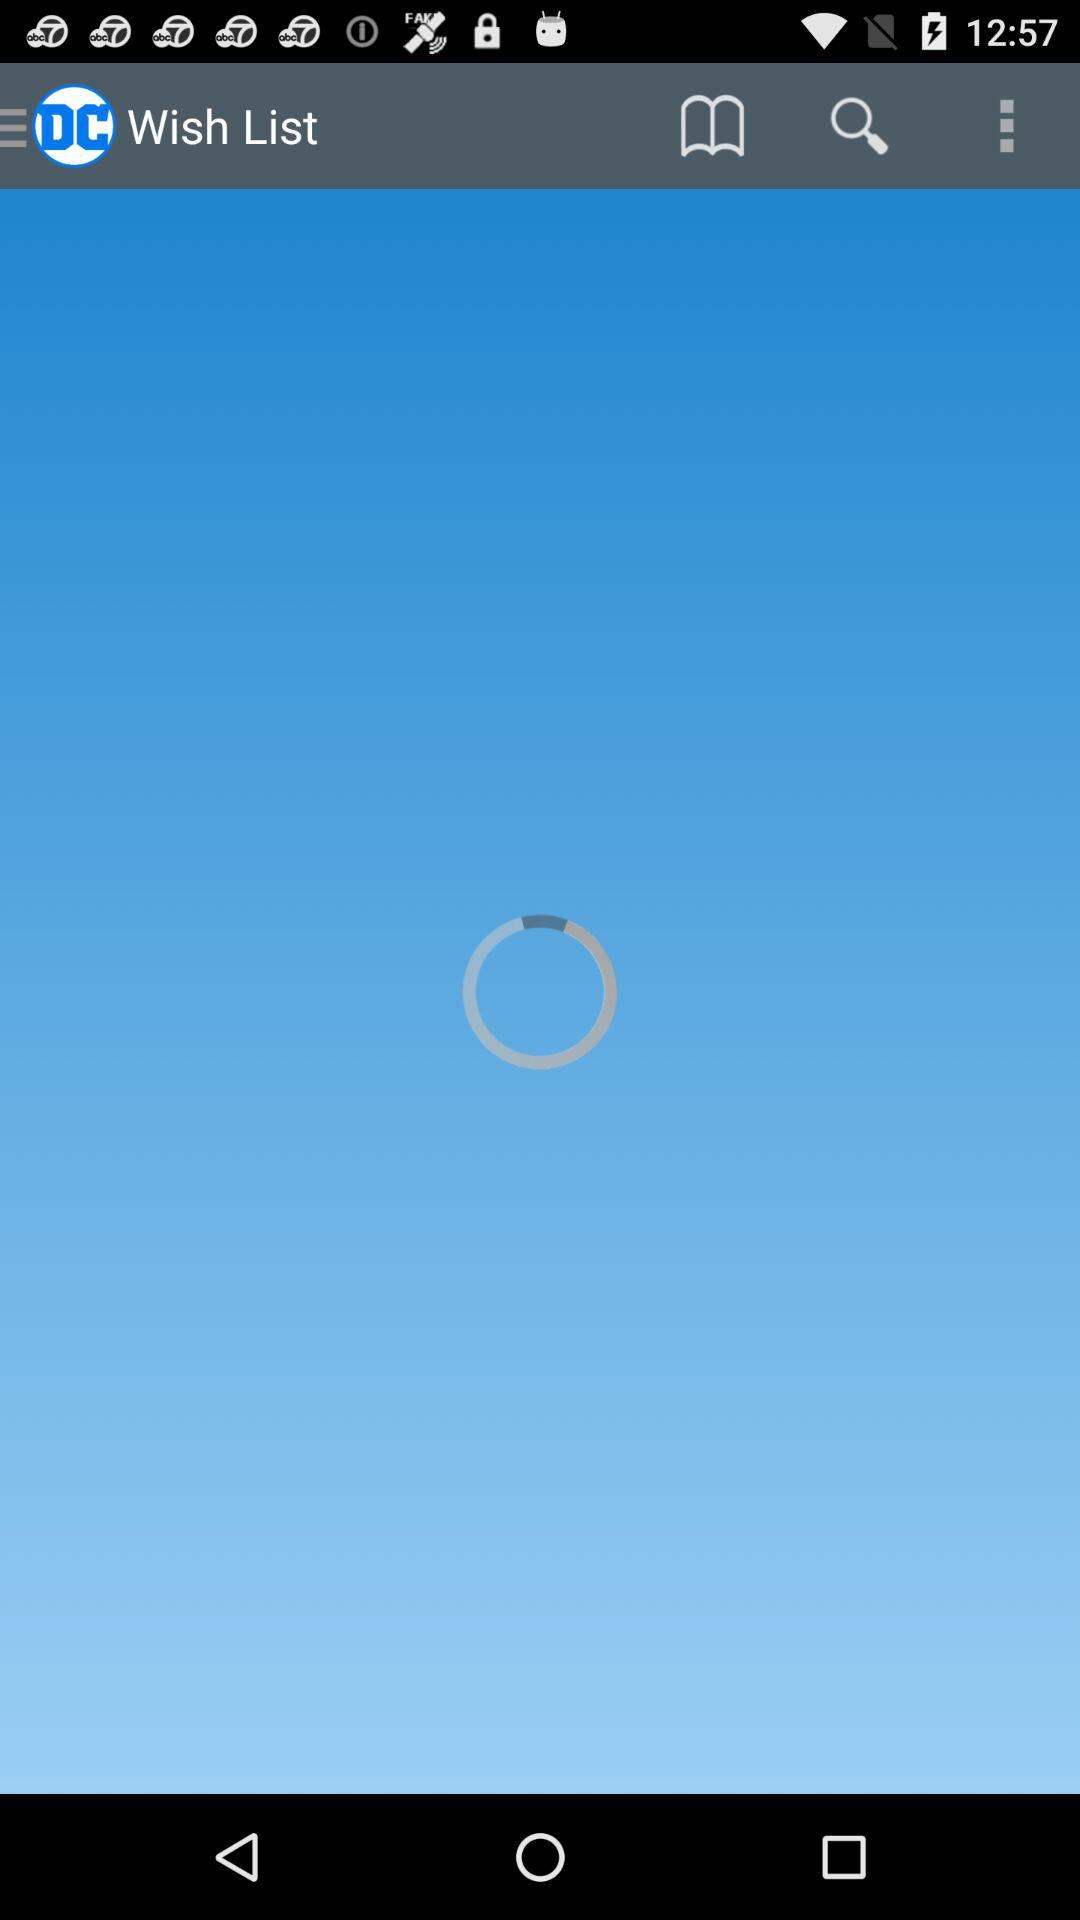What is the name of the application? The name of the application is "DC". 